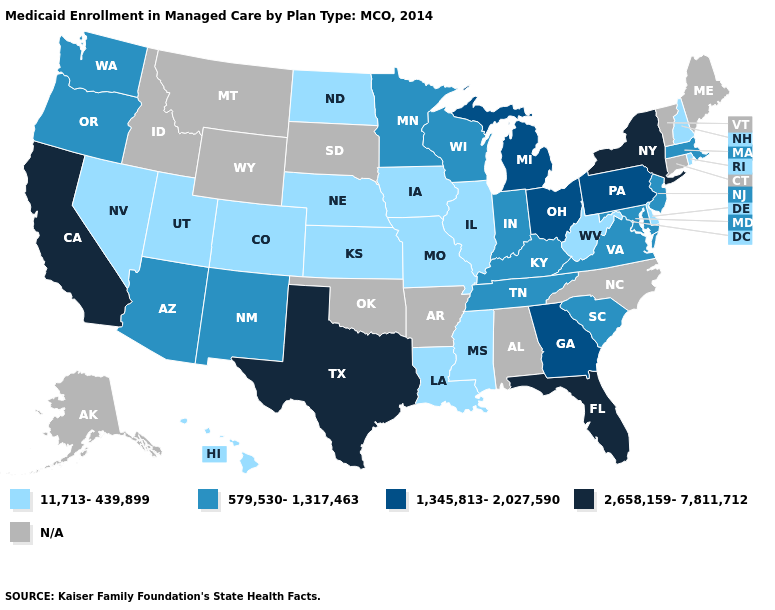What is the value of Virginia?
Answer briefly. 579,530-1,317,463. Does the map have missing data?
Quick response, please. Yes. Name the states that have a value in the range 11,713-439,899?
Answer briefly. Colorado, Delaware, Hawaii, Illinois, Iowa, Kansas, Louisiana, Mississippi, Missouri, Nebraska, Nevada, New Hampshire, North Dakota, Rhode Island, Utah, West Virginia. Among the states that border Mississippi , which have the highest value?
Short answer required. Tennessee. Name the states that have a value in the range 11,713-439,899?
Write a very short answer. Colorado, Delaware, Hawaii, Illinois, Iowa, Kansas, Louisiana, Mississippi, Missouri, Nebraska, Nevada, New Hampshire, North Dakota, Rhode Island, Utah, West Virginia. Does New York have the highest value in the Northeast?
Short answer required. Yes. What is the value of Mississippi?
Answer briefly. 11,713-439,899. What is the lowest value in the USA?
Concise answer only. 11,713-439,899. Name the states that have a value in the range 579,530-1,317,463?
Write a very short answer. Arizona, Indiana, Kentucky, Maryland, Massachusetts, Minnesota, New Jersey, New Mexico, Oregon, South Carolina, Tennessee, Virginia, Washington, Wisconsin. Among the states that border Michigan , does Indiana have the highest value?
Answer briefly. No. Name the states that have a value in the range N/A?
Answer briefly. Alabama, Alaska, Arkansas, Connecticut, Idaho, Maine, Montana, North Carolina, Oklahoma, South Dakota, Vermont, Wyoming. Which states hav the highest value in the Northeast?
Give a very brief answer. New York. Among the states that border Iowa , does Wisconsin have the highest value?
Be succinct. Yes. What is the value of Oregon?
Write a very short answer. 579,530-1,317,463. Does Kansas have the lowest value in the USA?
Short answer required. Yes. 